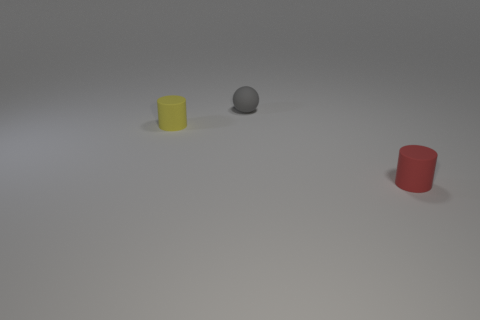Add 2 tiny brown rubber spheres. How many objects exist? 5 Subtract all balls. How many objects are left? 2 Add 3 tiny yellow metal blocks. How many tiny yellow metal blocks exist? 3 Subtract 0 red spheres. How many objects are left? 3 Subtract all blue cylinders. Subtract all green cubes. How many cylinders are left? 2 Subtract all cyan matte balls. Subtract all tiny spheres. How many objects are left? 2 Add 3 tiny yellow rubber things. How many tiny yellow rubber things are left? 4 